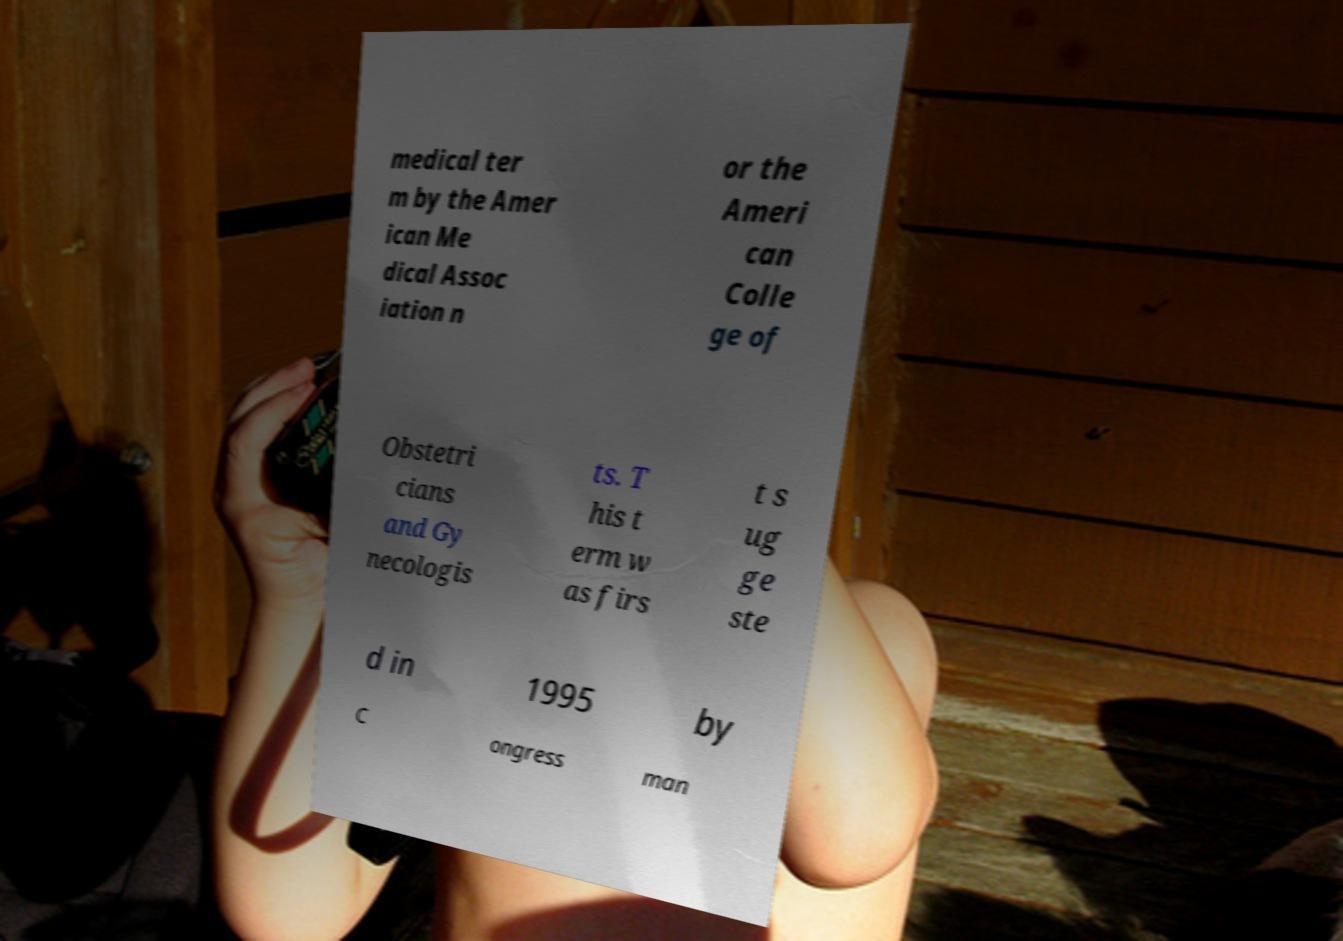For documentation purposes, I need the text within this image transcribed. Could you provide that? medical ter m by the Amer ican Me dical Assoc iation n or the Ameri can Colle ge of Obstetri cians and Gy necologis ts. T his t erm w as firs t s ug ge ste d in 1995 by C ongress man 